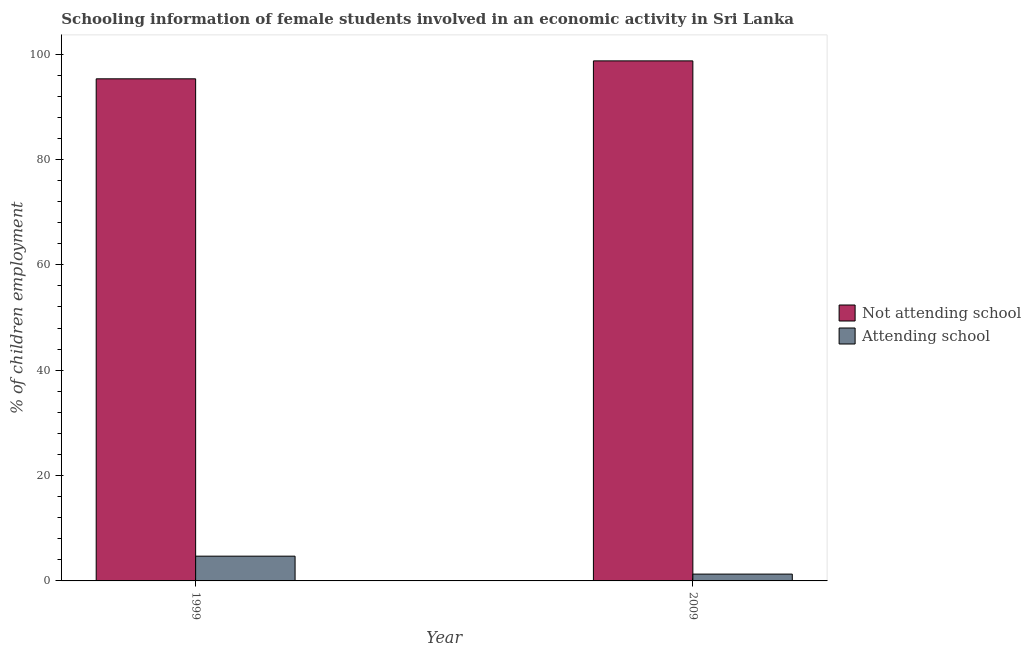How many different coloured bars are there?
Your answer should be very brief. 2. How many groups of bars are there?
Your response must be concise. 2. How many bars are there on the 1st tick from the left?
Ensure brevity in your answer.  2. How many bars are there on the 1st tick from the right?
Provide a succinct answer. 2. What is the label of the 2nd group of bars from the left?
Provide a short and direct response. 2009. In how many cases, is the number of bars for a given year not equal to the number of legend labels?
Give a very brief answer. 0. What is the percentage of employed females who are attending school in 2009?
Offer a very short reply. 1.29. Across all years, what is the maximum percentage of employed females who are not attending school?
Your answer should be compact. 98.71. Across all years, what is the minimum percentage of employed females who are attending school?
Provide a succinct answer. 1.29. In which year was the percentage of employed females who are attending school maximum?
Give a very brief answer. 1999. What is the total percentage of employed females who are not attending school in the graph?
Your answer should be compact. 194.01. What is the difference between the percentage of employed females who are attending school in 1999 and that in 2009?
Make the answer very short. 3.41. What is the difference between the percentage of employed females who are not attending school in 2009 and the percentage of employed females who are attending school in 1999?
Offer a very short reply. 3.41. What is the average percentage of employed females who are attending school per year?
Give a very brief answer. 3. In the year 2009, what is the difference between the percentage of employed females who are attending school and percentage of employed females who are not attending school?
Your response must be concise. 0. What is the ratio of the percentage of employed females who are attending school in 1999 to that in 2009?
Your answer should be very brief. 3.63. Is the percentage of employed females who are attending school in 1999 less than that in 2009?
Provide a short and direct response. No. What does the 1st bar from the left in 1999 represents?
Make the answer very short. Not attending school. What does the 2nd bar from the right in 1999 represents?
Ensure brevity in your answer.  Not attending school. Are the values on the major ticks of Y-axis written in scientific E-notation?
Provide a short and direct response. No. Does the graph contain any zero values?
Your answer should be compact. No. Does the graph contain grids?
Your answer should be very brief. No. What is the title of the graph?
Provide a short and direct response. Schooling information of female students involved in an economic activity in Sri Lanka. What is the label or title of the X-axis?
Make the answer very short. Year. What is the label or title of the Y-axis?
Keep it short and to the point. % of children employment. What is the % of children employment of Not attending school in 1999?
Give a very brief answer. 95.3. What is the % of children employment in Attending school in 1999?
Your answer should be compact. 4.7. What is the % of children employment in Not attending school in 2009?
Provide a succinct answer. 98.71. What is the % of children employment of Attending school in 2009?
Keep it short and to the point. 1.29. Across all years, what is the maximum % of children employment in Not attending school?
Your answer should be compact. 98.71. Across all years, what is the minimum % of children employment in Not attending school?
Your answer should be compact. 95.3. Across all years, what is the minimum % of children employment of Attending school?
Your answer should be compact. 1.29. What is the total % of children employment in Not attending school in the graph?
Provide a succinct answer. 194. What is the total % of children employment of Attending school in the graph?
Provide a short and direct response. 6. What is the difference between the % of children employment of Not attending school in 1999 and that in 2009?
Keep it short and to the point. -3.4. What is the difference between the % of children employment of Attending school in 1999 and that in 2009?
Ensure brevity in your answer.  3.4. What is the difference between the % of children employment of Not attending school in 1999 and the % of children employment of Attending school in 2009?
Give a very brief answer. 94. What is the average % of children employment in Not attending school per year?
Offer a very short reply. 97. What is the average % of children employment in Attending school per year?
Provide a succinct answer. 3. In the year 1999, what is the difference between the % of children employment of Not attending school and % of children employment of Attending school?
Provide a short and direct response. 90.6. In the year 2009, what is the difference between the % of children employment in Not attending school and % of children employment in Attending school?
Keep it short and to the point. 97.41. What is the ratio of the % of children employment in Not attending school in 1999 to that in 2009?
Ensure brevity in your answer.  0.97. What is the ratio of the % of children employment in Attending school in 1999 to that in 2009?
Your response must be concise. 3.63. What is the difference between the highest and the second highest % of children employment of Not attending school?
Make the answer very short. 3.4. What is the difference between the highest and the second highest % of children employment in Attending school?
Ensure brevity in your answer.  3.4. What is the difference between the highest and the lowest % of children employment in Not attending school?
Give a very brief answer. 3.4. What is the difference between the highest and the lowest % of children employment in Attending school?
Give a very brief answer. 3.4. 